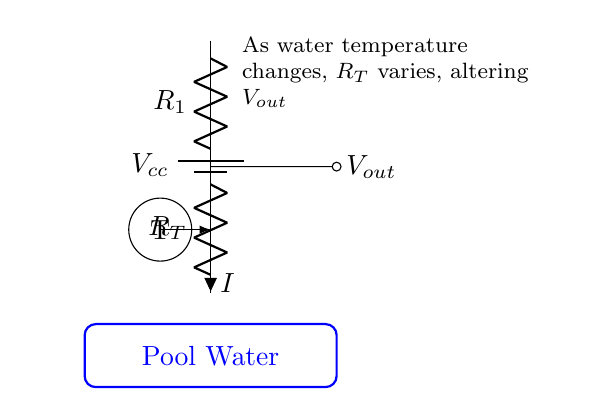What components are in the circuit? The circuit includes a battery, two resistors (R1 and RT), and a thermistor. The battery supplies the voltage, the resistors divide the voltage, and the thermistor measures temperature.
Answer: battery, R1, RT, thermistor What does Vout represent? Vout is the output voltage from the voltage divider, reflecting the temperature-dependent resistance of the thermistor. As temperature changes, the resistance of RT alters the value of Vout.
Answer: output voltage What happens to Vout if the temperature increases? If the temperature increases, the resistance RT of the thermistor typically decreases, which in turn lowers the output voltage Vout due to the voltage divider principle.
Answer: decreases How is the current I defined in this circuit? Current I is defined as the flow of charge through the resistors R1 and RT, dictated by the voltage Vcc from the battery and the resistance values. According to Ohm's law, I can be calculated using the arrangement of resistors.
Answer: flow of charge What role does the thermistor play in the voltage divider? The thermistor provides a resistance that changes with temperature, allowing Vout to reflect the water temperature by varying the output voltage of the divider. As the temperature changes, RT's resistance shifts, modifying Vout accordingly.
Answer: measures temperature What is the significance of R1 in the circuit? R1 sets a reference resistance that, in conjunction with the thermistor RT, allows for the accurate division of voltage, enabling measurement of temperature changes through Vout. It affects the stability and responsiveness of the output voltage.
Answer: reference resistance 